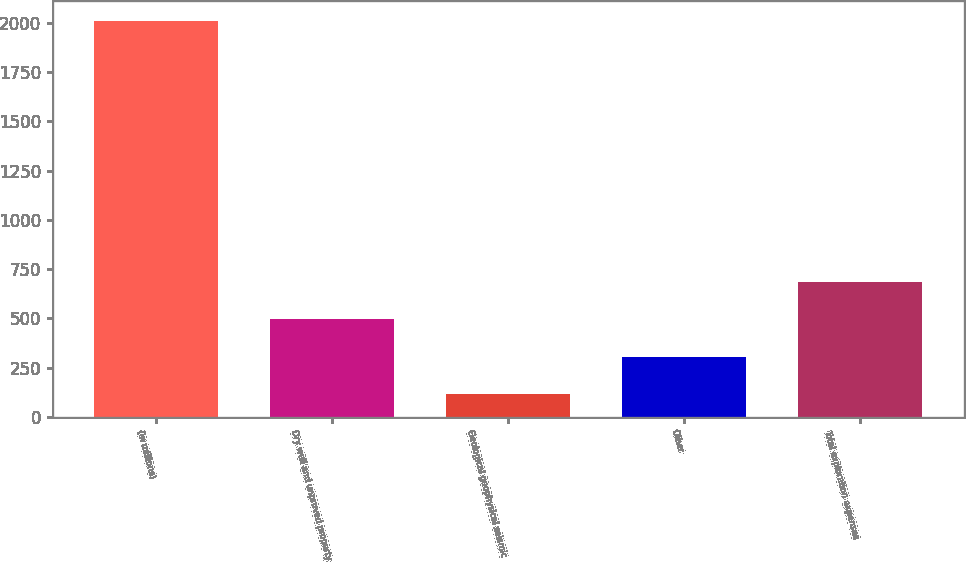<chart> <loc_0><loc_0><loc_500><loc_500><bar_chart><fcel>(In millions)<fcel>Dry well and unproved property<fcel>Geological geophysical seismic<fcel>Other<fcel>Total exploration expenses<nl><fcel>2010<fcel>494.8<fcel>116<fcel>305.4<fcel>684.2<nl></chart> 